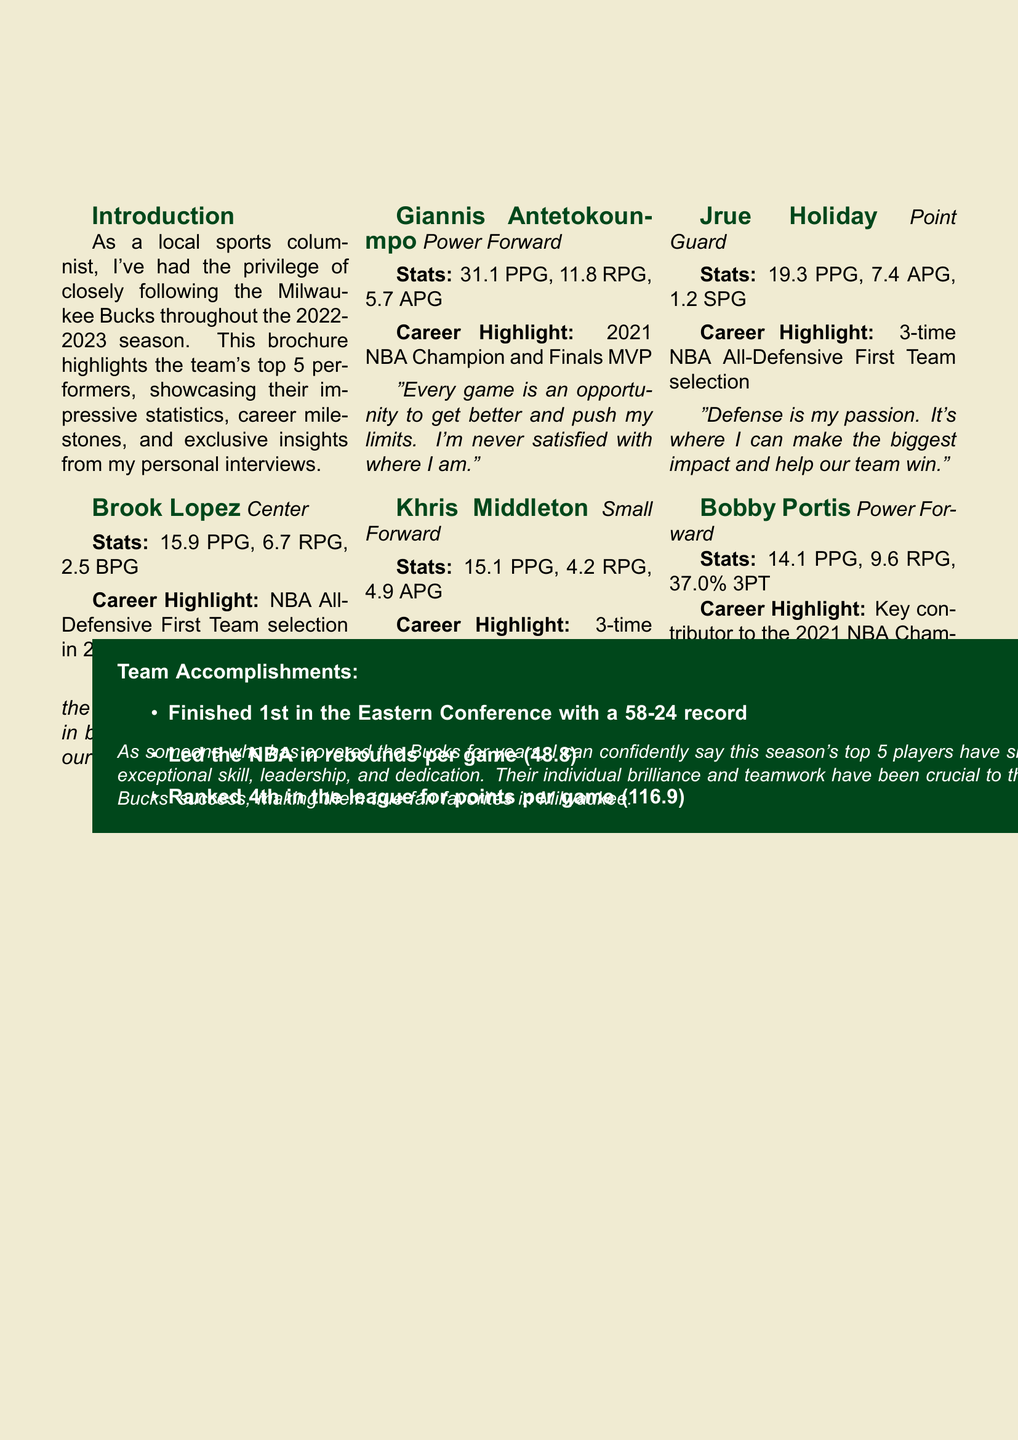What is the title of the brochure? The title of the brochure is stated at the top of the document.
Answer: Milwaukee Bucks: Top 5 Players of 2022-2023 Who is the power forward with the highest points per game? The document lists player statistics, and Giannis Antetokounmpo has the highest points per game among power forwards.
Answer: Giannis Antetokounmpo What was the team's record for the 2022-2023 season? The brochure mentions the Bucks' record as part of their accomplishments.
Answer: 58-24 Which player has a career highlight of being a 3-time NBA All-Star? The document includes career highlights for each player, identifying Khris Middleton as a 3-time NBA All-Star.
Answer: Khris Middleton What is Jrue Holiday's steals per game? The brochure provides specific statistics for each player, including Jrue Holiday's steals per game.
Answer: 1.2 Which player stated, "I bring energy every night"? The document contains exclusive quotes from the players, and this quote is attributed to Bobby Portis.
Answer: Bobby Portis What position does Brook Lopez play? The position of each player is indicated in the brochure.
Answer: Center How many times has Jrue Holiday been selected for the NBA All-Defensive First Team? The document mentions Jrue Holiday's career highlight, which indicates his selection count.
Answer: 3 times 